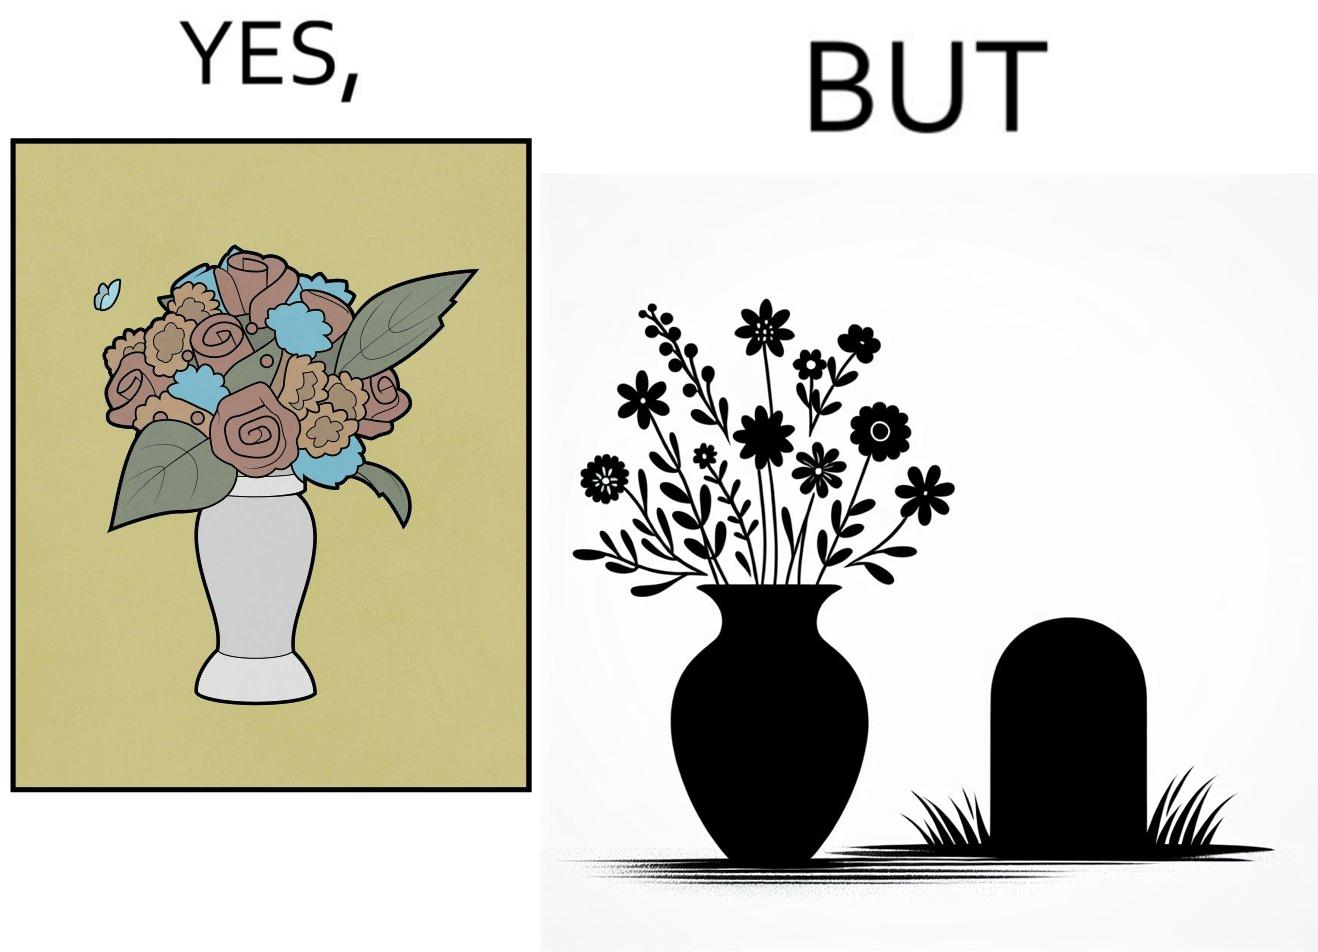What is shown in this image? The image is ironic, because in the first image a vase full of different beautiful flowers is seen which spreads a feeling of positivity, cheerfulness etc., whereas in the second image when the same vase is put in front of a grave stone it produces a feeling of sorrow 